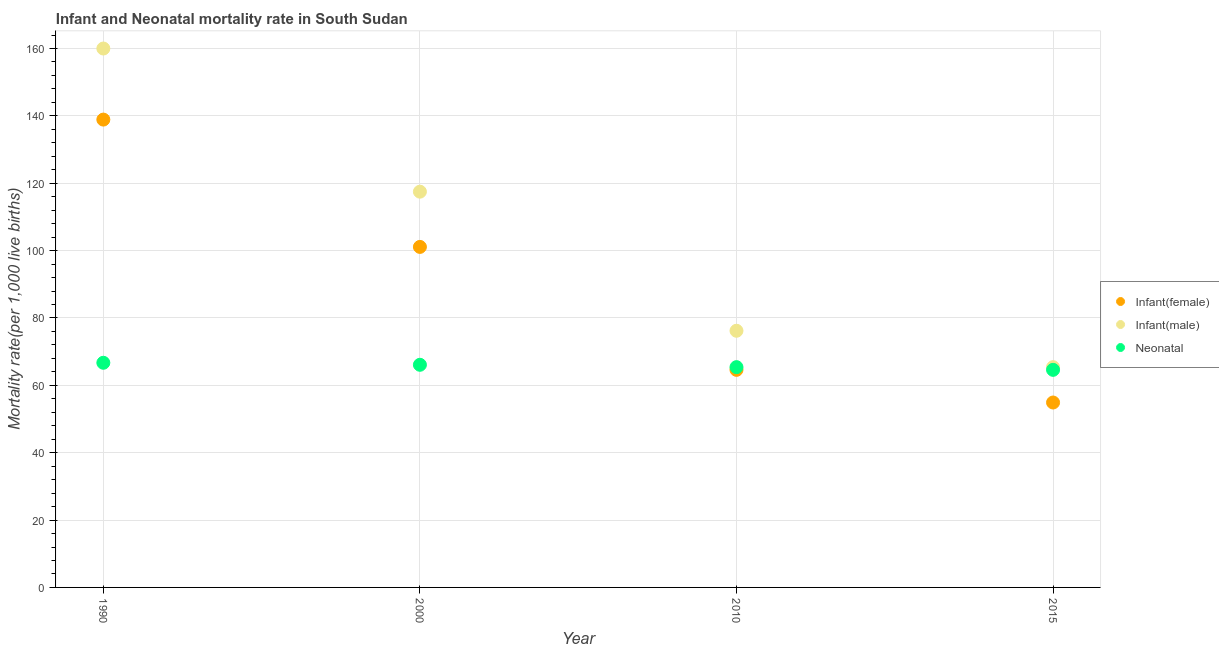What is the infant mortality rate(female) in 2010?
Offer a very short reply. 64.6. Across all years, what is the maximum neonatal mortality rate?
Your response must be concise. 66.7. Across all years, what is the minimum neonatal mortality rate?
Your response must be concise. 64.6. In which year was the infant mortality rate(female) maximum?
Provide a succinct answer. 1990. In which year was the infant mortality rate(male) minimum?
Provide a short and direct response. 2015. What is the total infant mortality rate(male) in the graph?
Give a very brief answer. 419.1. What is the difference between the neonatal mortality rate in 1990 and that in 2010?
Keep it short and to the point. 1.3. What is the difference between the infant mortality rate(male) in 1990 and the infant mortality rate(female) in 2000?
Make the answer very short. 58.9. What is the average infant mortality rate(male) per year?
Provide a short and direct response. 104.78. In the year 2010, what is the difference between the infant mortality rate(male) and infant mortality rate(female)?
Keep it short and to the point. 11.6. In how many years, is the infant mortality rate(female) greater than 44?
Your response must be concise. 4. What is the ratio of the infant mortality rate(female) in 1990 to that in 2000?
Make the answer very short. 1.37. What is the difference between the highest and the second highest neonatal mortality rate?
Keep it short and to the point. 0.6. Is the sum of the infant mortality rate(female) in 2000 and 2010 greater than the maximum infant mortality rate(male) across all years?
Ensure brevity in your answer.  Yes. Is it the case that in every year, the sum of the infant mortality rate(female) and infant mortality rate(male) is greater than the neonatal mortality rate?
Your answer should be compact. Yes. Is the neonatal mortality rate strictly greater than the infant mortality rate(female) over the years?
Offer a very short reply. No. How many dotlines are there?
Your response must be concise. 3. What is the difference between two consecutive major ticks on the Y-axis?
Provide a succinct answer. 20. How are the legend labels stacked?
Make the answer very short. Vertical. What is the title of the graph?
Make the answer very short. Infant and Neonatal mortality rate in South Sudan. Does "Coal" appear as one of the legend labels in the graph?
Make the answer very short. No. What is the label or title of the X-axis?
Provide a succinct answer. Year. What is the label or title of the Y-axis?
Ensure brevity in your answer.  Mortality rate(per 1,0 live births). What is the Mortality rate(per 1,000 live births) of Infant(female) in 1990?
Your answer should be compact. 138.9. What is the Mortality rate(per 1,000 live births) of Infant(male) in 1990?
Provide a succinct answer. 160. What is the Mortality rate(per 1,000 live births) of Neonatal  in 1990?
Keep it short and to the point. 66.7. What is the Mortality rate(per 1,000 live births) in Infant(female) in 2000?
Make the answer very short. 101.1. What is the Mortality rate(per 1,000 live births) of Infant(male) in 2000?
Offer a very short reply. 117.5. What is the Mortality rate(per 1,000 live births) of Neonatal  in 2000?
Make the answer very short. 66.1. What is the Mortality rate(per 1,000 live births) of Infant(female) in 2010?
Give a very brief answer. 64.6. What is the Mortality rate(per 1,000 live births) of Infant(male) in 2010?
Your answer should be very brief. 76.2. What is the Mortality rate(per 1,000 live births) of Neonatal  in 2010?
Your answer should be compact. 65.4. What is the Mortality rate(per 1,000 live births) of Infant(female) in 2015?
Your response must be concise. 54.9. What is the Mortality rate(per 1,000 live births) of Infant(male) in 2015?
Provide a succinct answer. 65.4. What is the Mortality rate(per 1,000 live births) in Neonatal  in 2015?
Offer a very short reply. 64.6. Across all years, what is the maximum Mortality rate(per 1,000 live births) of Infant(female)?
Keep it short and to the point. 138.9. Across all years, what is the maximum Mortality rate(per 1,000 live births) in Infant(male)?
Make the answer very short. 160. Across all years, what is the maximum Mortality rate(per 1,000 live births) in Neonatal ?
Ensure brevity in your answer.  66.7. Across all years, what is the minimum Mortality rate(per 1,000 live births) in Infant(female)?
Offer a very short reply. 54.9. Across all years, what is the minimum Mortality rate(per 1,000 live births) in Infant(male)?
Give a very brief answer. 65.4. Across all years, what is the minimum Mortality rate(per 1,000 live births) of Neonatal ?
Your answer should be very brief. 64.6. What is the total Mortality rate(per 1,000 live births) of Infant(female) in the graph?
Provide a short and direct response. 359.5. What is the total Mortality rate(per 1,000 live births) of Infant(male) in the graph?
Your answer should be very brief. 419.1. What is the total Mortality rate(per 1,000 live births) of Neonatal  in the graph?
Offer a very short reply. 262.8. What is the difference between the Mortality rate(per 1,000 live births) in Infant(female) in 1990 and that in 2000?
Give a very brief answer. 37.8. What is the difference between the Mortality rate(per 1,000 live births) of Infant(male) in 1990 and that in 2000?
Your answer should be compact. 42.5. What is the difference between the Mortality rate(per 1,000 live births) in Neonatal  in 1990 and that in 2000?
Your answer should be compact. 0.6. What is the difference between the Mortality rate(per 1,000 live births) in Infant(female) in 1990 and that in 2010?
Give a very brief answer. 74.3. What is the difference between the Mortality rate(per 1,000 live births) of Infant(male) in 1990 and that in 2010?
Your answer should be compact. 83.8. What is the difference between the Mortality rate(per 1,000 live births) of Neonatal  in 1990 and that in 2010?
Your answer should be very brief. 1.3. What is the difference between the Mortality rate(per 1,000 live births) in Infant(male) in 1990 and that in 2015?
Give a very brief answer. 94.6. What is the difference between the Mortality rate(per 1,000 live births) of Infant(female) in 2000 and that in 2010?
Give a very brief answer. 36.5. What is the difference between the Mortality rate(per 1,000 live births) in Infant(male) in 2000 and that in 2010?
Your response must be concise. 41.3. What is the difference between the Mortality rate(per 1,000 live births) of Neonatal  in 2000 and that in 2010?
Your response must be concise. 0.7. What is the difference between the Mortality rate(per 1,000 live births) in Infant(female) in 2000 and that in 2015?
Keep it short and to the point. 46.2. What is the difference between the Mortality rate(per 1,000 live births) in Infant(male) in 2000 and that in 2015?
Offer a terse response. 52.1. What is the difference between the Mortality rate(per 1,000 live births) in Infant(female) in 2010 and that in 2015?
Your answer should be very brief. 9.7. What is the difference between the Mortality rate(per 1,000 live births) in Infant(female) in 1990 and the Mortality rate(per 1,000 live births) in Infant(male) in 2000?
Offer a terse response. 21.4. What is the difference between the Mortality rate(per 1,000 live births) in Infant(female) in 1990 and the Mortality rate(per 1,000 live births) in Neonatal  in 2000?
Provide a short and direct response. 72.8. What is the difference between the Mortality rate(per 1,000 live births) in Infant(male) in 1990 and the Mortality rate(per 1,000 live births) in Neonatal  in 2000?
Ensure brevity in your answer.  93.9. What is the difference between the Mortality rate(per 1,000 live births) of Infant(female) in 1990 and the Mortality rate(per 1,000 live births) of Infant(male) in 2010?
Offer a very short reply. 62.7. What is the difference between the Mortality rate(per 1,000 live births) of Infant(female) in 1990 and the Mortality rate(per 1,000 live births) of Neonatal  in 2010?
Provide a short and direct response. 73.5. What is the difference between the Mortality rate(per 1,000 live births) in Infant(male) in 1990 and the Mortality rate(per 1,000 live births) in Neonatal  in 2010?
Your response must be concise. 94.6. What is the difference between the Mortality rate(per 1,000 live births) of Infant(female) in 1990 and the Mortality rate(per 1,000 live births) of Infant(male) in 2015?
Give a very brief answer. 73.5. What is the difference between the Mortality rate(per 1,000 live births) in Infant(female) in 1990 and the Mortality rate(per 1,000 live births) in Neonatal  in 2015?
Ensure brevity in your answer.  74.3. What is the difference between the Mortality rate(per 1,000 live births) in Infant(male) in 1990 and the Mortality rate(per 1,000 live births) in Neonatal  in 2015?
Your response must be concise. 95.4. What is the difference between the Mortality rate(per 1,000 live births) in Infant(female) in 2000 and the Mortality rate(per 1,000 live births) in Infant(male) in 2010?
Provide a succinct answer. 24.9. What is the difference between the Mortality rate(per 1,000 live births) of Infant(female) in 2000 and the Mortality rate(per 1,000 live births) of Neonatal  in 2010?
Your answer should be very brief. 35.7. What is the difference between the Mortality rate(per 1,000 live births) in Infant(male) in 2000 and the Mortality rate(per 1,000 live births) in Neonatal  in 2010?
Provide a short and direct response. 52.1. What is the difference between the Mortality rate(per 1,000 live births) of Infant(female) in 2000 and the Mortality rate(per 1,000 live births) of Infant(male) in 2015?
Provide a short and direct response. 35.7. What is the difference between the Mortality rate(per 1,000 live births) of Infant(female) in 2000 and the Mortality rate(per 1,000 live births) of Neonatal  in 2015?
Your answer should be compact. 36.5. What is the difference between the Mortality rate(per 1,000 live births) of Infant(male) in 2000 and the Mortality rate(per 1,000 live births) of Neonatal  in 2015?
Your answer should be very brief. 52.9. What is the difference between the Mortality rate(per 1,000 live births) in Infant(female) in 2010 and the Mortality rate(per 1,000 live births) in Infant(male) in 2015?
Ensure brevity in your answer.  -0.8. What is the difference between the Mortality rate(per 1,000 live births) in Infant(male) in 2010 and the Mortality rate(per 1,000 live births) in Neonatal  in 2015?
Give a very brief answer. 11.6. What is the average Mortality rate(per 1,000 live births) of Infant(female) per year?
Provide a succinct answer. 89.88. What is the average Mortality rate(per 1,000 live births) of Infant(male) per year?
Your answer should be compact. 104.78. What is the average Mortality rate(per 1,000 live births) of Neonatal  per year?
Provide a succinct answer. 65.7. In the year 1990, what is the difference between the Mortality rate(per 1,000 live births) of Infant(female) and Mortality rate(per 1,000 live births) of Infant(male)?
Your answer should be compact. -21.1. In the year 1990, what is the difference between the Mortality rate(per 1,000 live births) of Infant(female) and Mortality rate(per 1,000 live births) of Neonatal ?
Make the answer very short. 72.2. In the year 1990, what is the difference between the Mortality rate(per 1,000 live births) of Infant(male) and Mortality rate(per 1,000 live births) of Neonatal ?
Make the answer very short. 93.3. In the year 2000, what is the difference between the Mortality rate(per 1,000 live births) of Infant(female) and Mortality rate(per 1,000 live births) of Infant(male)?
Make the answer very short. -16.4. In the year 2000, what is the difference between the Mortality rate(per 1,000 live births) of Infant(female) and Mortality rate(per 1,000 live births) of Neonatal ?
Your answer should be compact. 35. In the year 2000, what is the difference between the Mortality rate(per 1,000 live births) of Infant(male) and Mortality rate(per 1,000 live births) of Neonatal ?
Your answer should be compact. 51.4. In the year 2010, what is the difference between the Mortality rate(per 1,000 live births) in Infant(female) and Mortality rate(per 1,000 live births) in Infant(male)?
Give a very brief answer. -11.6. In the year 2010, what is the difference between the Mortality rate(per 1,000 live births) in Infant(female) and Mortality rate(per 1,000 live births) in Neonatal ?
Provide a succinct answer. -0.8. In the year 2015, what is the difference between the Mortality rate(per 1,000 live births) of Infant(female) and Mortality rate(per 1,000 live births) of Neonatal ?
Provide a short and direct response. -9.7. In the year 2015, what is the difference between the Mortality rate(per 1,000 live births) in Infant(male) and Mortality rate(per 1,000 live births) in Neonatal ?
Provide a succinct answer. 0.8. What is the ratio of the Mortality rate(per 1,000 live births) of Infant(female) in 1990 to that in 2000?
Your response must be concise. 1.37. What is the ratio of the Mortality rate(per 1,000 live births) in Infant(male) in 1990 to that in 2000?
Your answer should be very brief. 1.36. What is the ratio of the Mortality rate(per 1,000 live births) of Neonatal  in 1990 to that in 2000?
Ensure brevity in your answer.  1.01. What is the ratio of the Mortality rate(per 1,000 live births) in Infant(female) in 1990 to that in 2010?
Offer a terse response. 2.15. What is the ratio of the Mortality rate(per 1,000 live births) of Infant(male) in 1990 to that in 2010?
Your answer should be very brief. 2.1. What is the ratio of the Mortality rate(per 1,000 live births) of Neonatal  in 1990 to that in 2010?
Ensure brevity in your answer.  1.02. What is the ratio of the Mortality rate(per 1,000 live births) in Infant(female) in 1990 to that in 2015?
Your answer should be very brief. 2.53. What is the ratio of the Mortality rate(per 1,000 live births) in Infant(male) in 1990 to that in 2015?
Offer a terse response. 2.45. What is the ratio of the Mortality rate(per 1,000 live births) of Neonatal  in 1990 to that in 2015?
Your answer should be very brief. 1.03. What is the ratio of the Mortality rate(per 1,000 live births) of Infant(female) in 2000 to that in 2010?
Offer a terse response. 1.56. What is the ratio of the Mortality rate(per 1,000 live births) in Infant(male) in 2000 to that in 2010?
Your answer should be compact. 1.54. What is the ratio of the Mortality rate(per 1,000 live births) in Neonatal  in 2000 to that in 2010?
Ensure brevity in your answer.  1.01. What is the ratio of the Mortality rate(per 1,000 live births) of Infant(female) in 2000 to that in 2015?
Offer a very short reply. 1.84. What is the ratio of the Mortality rate(per 1,000 live births) in Infant(male) in 2000 to that in 2015?
Offer a terse response. 1.8. What is the ratio of the Mortality rate(per 1,000 live births) of Neonatal  in 2000 to that in 2015?
Provide a short and direct response. 1.02. What is the ratio of the Mortality rate(per 1,000 live births) of Infant(female) in 2010 to that in 2015?
Offer a terse response. 1.18. What is the ratio of the Mortality rate(per 1,000 live births) of Infant(male) in 2010 to that in 2015?
Keep it short and to the point. 1.17. What is the ratio of the Mortality rate(per 1,000 live births) in Neonatal  in 2010 to that in 2015?
Your response must be concise. 1.01. What is the difference between the highest and the second highest Mortality rate(per 1,000 live births) in Infant(female)?
Give a very brief answer. 37.8. What is the difference between the highest and the second highest Mortality rate(per 1,000 live births) of Infant(male)?
Your answer should be very brief. 42.5. What is the difference between the highest and the lowest Mortality rate(per 1,000 live births) in Infant(male)?
Your answer should be compact. 94.6. 